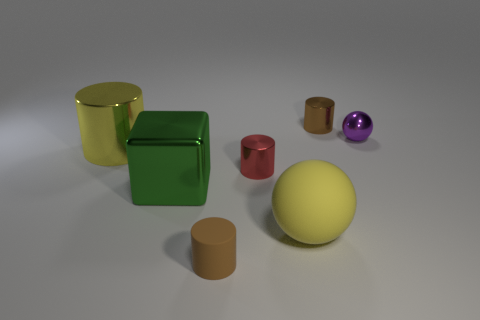Add 1 cyan shiny objects. How many objects exist? 8 Subtract all cylinders. How many objects are left? 3 Add 7 brown cylinders. How many brown cylinders are left? 9 Add 1 tiny brown matte things. How many tiny brown matte things exist? 2 Subtract 0 brown spheres. How many objects are left? 7 Subtract all yellow matte things. Subtract all red metallic cylinders. How many objects are left? 5 